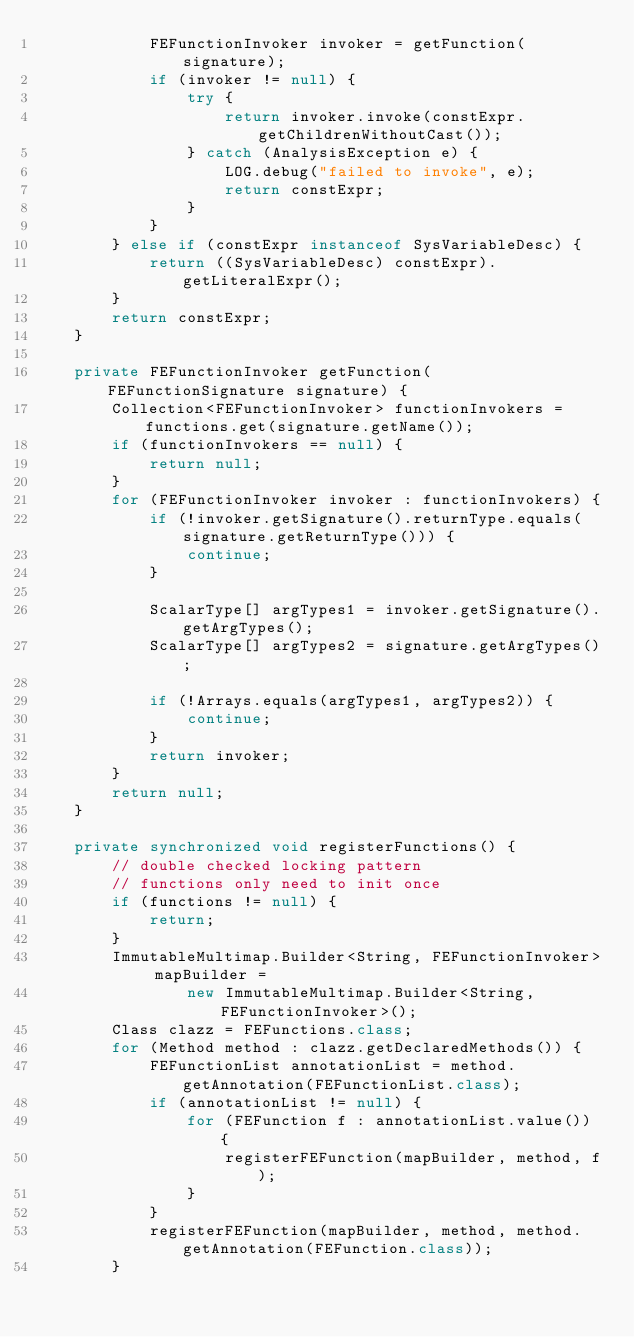Convert code to text. <code><loc_0><loc_0><loc_500><loc_500><_Java_>            FEFunctionInvoker invoker = getFunction(signature);
            if (invoker != null) {
                try {
                    return invoker.invoke(constExpr.getChildrenWithoutCast());
                } catch (AnalysisException e) {
                    LOG.debug("failed to invoke", e);
                    return constExpr;
                }
            }
        } else if (constExpr instanceof SysVariableDesc) {
            return ((SysVariableDesc) constExpr).getLiteralExpr();
        }
        return constExpr;
    }

    private FEFunctionInvoker getFunction(FEFunctionSignature signature) {
        Collection<FEFunctionInvoker> functionInvokers = functions.get(signature.getName());
        if (functionInvokers == null) {
            return null;
        }
        for (FEFunctionInvoker invoker : functionInvokers) {
            if (!invoker.getSignature().returnType.equals(signature.getReturnType())) {
                continue;
            }

            ScalarType[] argTypes1 = invoker.getSignature().getArgTypes();
            ScalarType[] argTypes2 = signature.getArgTypes();

            if (!Arrays.equals(argTypes1, argTypes2)) {
                continue;
            }
            return invoker;
        }
        return null;
    }

    private synchronized void registerFunctions() {
        // double checked locking pattern
        // functions only need to init once
        if (functions != null) {
            return;
        }
        ImmutableMultimap.Builder<String, FEFunctionInvoker> mapBuilder =
                new ImmutableMultimap.Builder<String, FEFunctionInvoker>();
        Class clazz = FEFunctions.class;
        for (Method method : clazz.getDeclaredMethods()) {
            FEFunctionList annotationList = method.getAnnotation(FEFunctionList.class);
            if (annotationList != null) {
                for (FEFunction f : annotationList.value()) {
                    registerFEFunction(mapBuilder, method, f);
                }
            }
            registerFEFunction(mapBuilder, method, method.getAnnotation(FEFunction.class));
        }</code> 